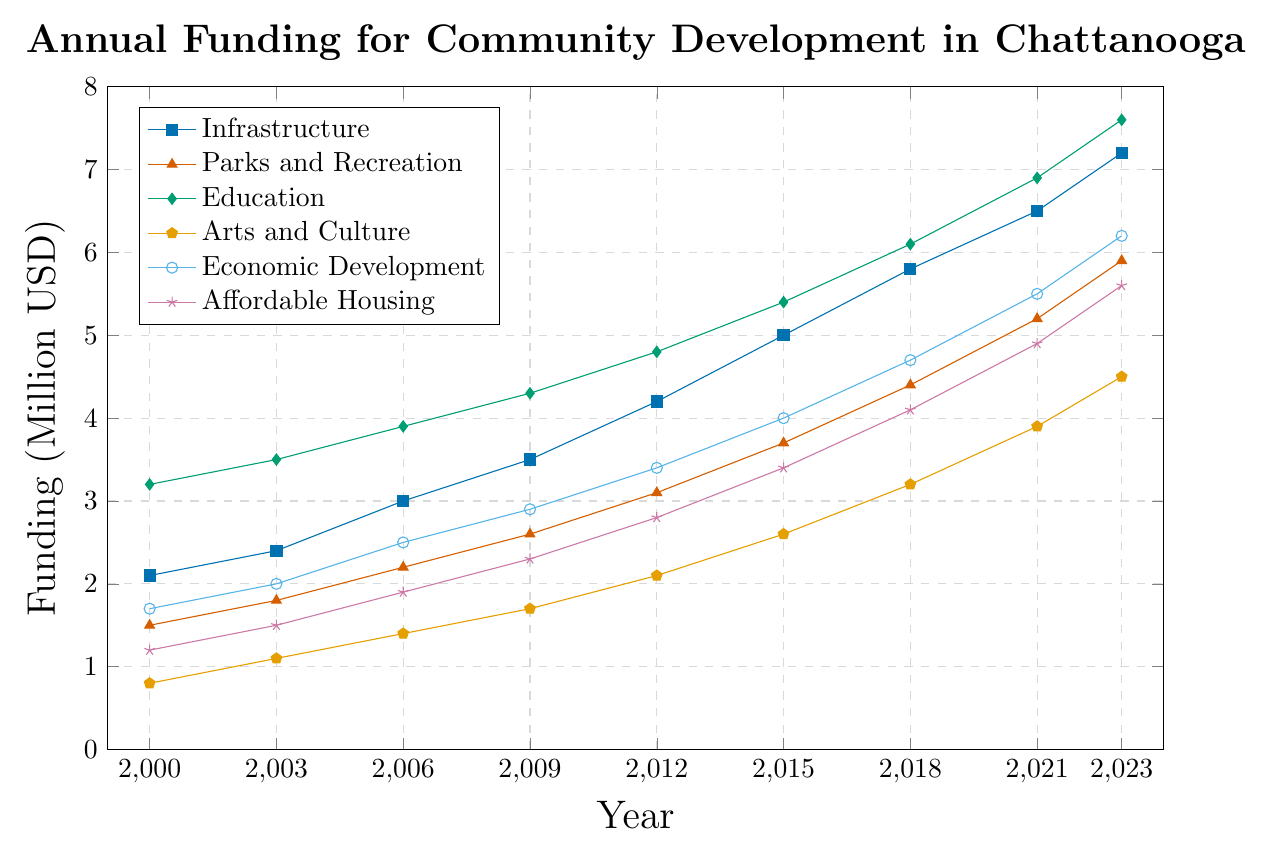What type of project has seen the most consistent increase in funding from 2000 to 2023? By examining the slope of the lines, Education shows a consistent upward trend from 3.2 million USD in 2000 to 7.6 million USD in 2023, the steepest and most consistent among the projects.
Answer: Education Which year had the highest total funding for all project types combined? Calculate the total funding for each year and compare them. For 2023: \(7.2 + 5.9 + 7.6 + 4.5 + 6.2 + 5.6 = 37\). For other years, the total is consistently less.
Answer: 2023 What is the average annual funding for Parks and Recreation between 2003 and 2021? Add the funding for Parks and Recreation for the years 2003, 2006, 2009, 2012, 2015, 2018, and 2021, then divide by 7. \(\frac{1.8 + 2.2 + 2.6 + 3.1 + 3.7 + 4.4 + 5.2}{7} = 3.29\) million USD
Answer: 3.29 In which year did Affordable Housing receive more funding than Parks and Recreation? Identify the years where the Affordable Housing line is above the Parks and Recreation line. This occurs only in 2009.
Answer: 2009 How does the funding for Infrastructure in 2006 compare to Economic Development in 2021? Look at the respective points on the chart: Infrastructure in 2006 is 3.0 million USD, Economic Development in 2021 is 5.5 million USD. So, Economic Development in 2021 is greater.
Answer: Economic Development in 2021 is greater Which project had the slowest growth in funding from 2000 to 2023? Compare the overall changes in funding levels from 2000 to 2023. Arts and Culture increased from 0.8 to 4.5, which is slower compared to others.
Answer: Arts and Culture What is the funding difference between Education and Affordable Housing in 2023? Subtract the funding of Affordable Housing from Education in 2023: \(7.6 - 5.6 = 2.0\) million USD
Answer: 2.0 million USD What is the total funding allocated to Education from 2000 to 2023? Sum the education funding values over the years: \(3.2 + 3.5 + 3.9 + 4.3 + 4.8 + 5.4 + 6.1 + 6.9 + 7.6 = 45.7\) million USD
Answer: 45.7 million USD 